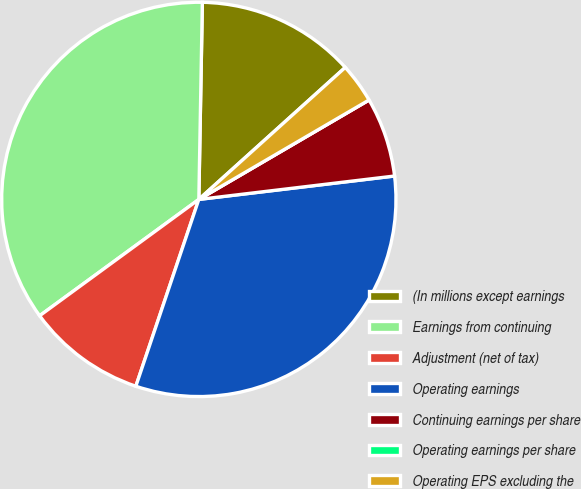Convert chart. <chart><loc_0><loc_0><loc_500><loc_500><pie_chart><fcel>(In millions except earnings<fcel>Earnings from continuing<fcel>Adjustment (net of tax)<fcel>Operating earnings<fcel>Continuing earnings per share<fcel>Operating earnings per share<fcel>Operating EPS excluding the<nl><fcel>13.04%<fcel>35.33%<fcel>9.78%<fcel>32.07%<fcel>6.52%<fcel>0.0%<fcel>3.26%<nl></chart> 